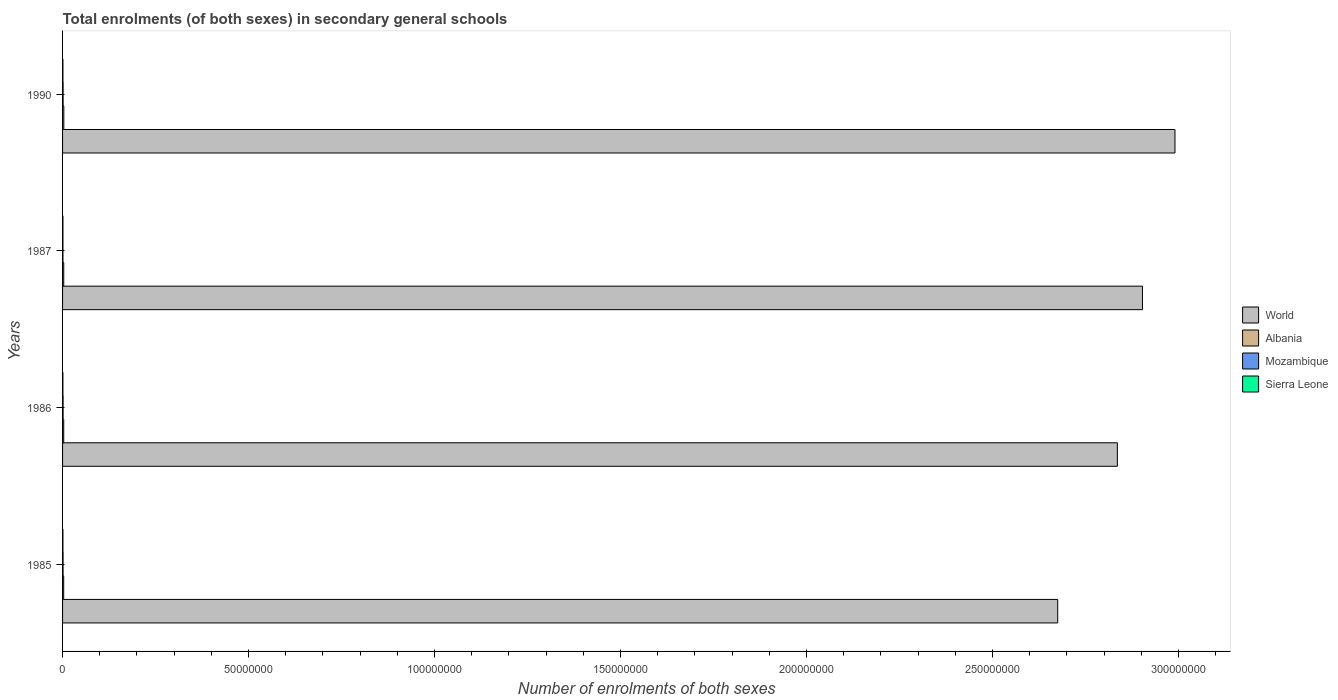How many bars are there on the 4th tick from the top?
Your answer should be very brief. 4. What is the label of the 3rd group of bars from the top?
Keep it short and to the point. 1986. In how many cases, is the number of bars for a given year not equal to the number of legend labels?
Give a very brief answer. 0. What is the number of enrolments in secondary schools in World in 1985?
Give a very brief answer. 2.68e+08. Across all years, what is the maximum number of enrolments in secondary schools in World?
Ensure brevity in your answer.  2.99e+08. Across all years, what is the minimum number of enrolments in secondary schools in World?
Provide a short and direct response. 2.68e+08. In which year was the number of enrolments in secondary schools in Albania maximum?
Your answer should be compact. 1990. In which year was the number of enrolments in secondary schools in World minimum?
Give a very brief answer. 1985. What is the total number of enrolments in secondary schools in Albania in the graph?
Your answer should be compact. 1.27e+06. What is the difference between the number of enrolments in secondary schools in Sierra Leone in 1986 and that in 1987?
Provide a succinct answer. -8178. What is the difference between the number of enrolments in secondary schools in Sierra Leone in 1990 and the number of enrolments in secondary schools in Albania in 1987?
Your response must be concise. -2.19e+05. What is the average number of enrolments in secondary schools in Albania per year?
Offer a terse response. 3.16e+05. In the year 1985, what is the difference between the number of enrolments in secondary schools in Albania and number of enrolments in secondary schools in Mozambique?
Provide a short and direct response. 1.68e+05. In how many years, is the number of enrolments in secondary schools in Albania greater than 70000000 ?
Offer a terse response. 0. What is the ratio of the number of enrolments in secondary schools in Albania in 1985 to that in 1986?
Ensure brevity in your answer.  0.97. Is the difference between the number of enrolments in secondary schools in Albania in 1985 and 1987 greater than the difference between the number of enrolments in secondary schools in Mozambique in 1985 and 1987?
Ensure brevity in your answer.  No. What is the difference between the highest and the second highest number of enrolments in secondary schools in Albania?
Ensure brevity in your answer.  1.91e+04. What is the difference between the highest and the lowest number of enrolments in secondary schools in Mozambique?
Your response must be concise. 4.20e+04. In how many years, is the number of enrolments in secondary schools in World greater than the average number of enrolments in secondary schools in World taken over all years?
Ensure brevity in your answer.  2. Is the sum of the number of enrolments in secondary schools in Albania in 1986 and 1987 greater than the maximum number of enrolments in secondary schools in World across all years?
Your response must be concise. No. What does the 1st bar from the top in 1987 represents?
Provide a succinct answer. Sierra Leone. How many bars are there?
Your answer should be very brief. 16. Are all the bars in the graph horizontal?
Offer a terse response. Yes. How many years are there in the graph?
Offer a very short reply. 4. Are the values on the major ticks of X-axis written in scientific E-notation?
Make the answer very short. No. Does the graph contain grids?
Offer a very short reply. No. Where does the legend appear in the graph?
Provide a short and direct response. Center right. How many legend labels are there?
Provide a succinct answer. 4. How are the legend labels stacked?
Keep it short and to the point. Vertical. What is the title of the graph?
Your answer should be compact. Total enrolments (of both sexes) in secondary general schools. What is the label or title of the X-axis?
Offer a terse response. Number of enrolments of both sexes. What is the Number of enrolments of both sexes in World in 1985?
Provide a succinct answer. 2.68e+08. What is the Number of enrolments of both sexes in Albania in 1985?
Offer a terse response. 3.03e+05. What is the Number of enrolments of both sexes of Mozambique in 1985?
Your response must be concise. 1.35e+05. What is the Number of enrolments of both sexes in Sierra Leone in 1985?
Your answer should be very brief. 9.71e+04. What is the Number of enrolments of both sexes in World in 1986?
Ensure brevity in your answer.  2.84e+08. What is the Number of enrolments of both sexes in Albania in 1986?
Give a very brief answer. 3.11e+05. What is the Number of enrolments of both sexes in Mozambique in 1986?
Give a very brief answer. 1.40e+05. What is the Number of enrolments of both sexes in Sierra Leone in 1986?
Your answer should be compact. 9.35e+04. What is the Number of enrolments of both sexes of World in 1987?
Keep it short and to the point. 2.90e+08. What is the Number of enrolments of both sexes in Albania in 1987?
Your answer should be very brief. 3.16e+05. What is the Number of enrolments of both sexes in Mozambique in 1987?
Ensure brevity in your answer.  1.03e+05. What is the Number of enrolments of both sexes in Sierra Leone in 1987?
Your answer should be compact. 1.02e+05. What is the Number of enrolments of both sexes in World in 1990?
Provide a short and direct response. 2.99e+08. What is the Number of enrolments of both sexes of Albania in 1990?
Provide a succinct answer. 3.35e+05. What is the Number of enrolments of both sexes in Mozambique in 1990?
Give a very brief answer. 1.45e+05. What is the Number of enrolments of both sexes in Sierra Leone in 1990?
Provide a succinct answer. 9.67e+04. Across all years, what is the maximum Number of enrolments of both sexes in World?
Ensure brevity in your answer.  2.99e+08. Across all years, what is the maximum Number of enrolments of both sexes of Albania?
Ensure brevity in your answer.  3.35e+05. Across all years, what is the maximum Number of enrolments of both sexes of Mozambique?
Make the answer very short. 1.45e+05. Across all years, what is the maximum Number of enrolments of both sexes of Sierra Leone?
Keep it short and to the point. 1.02e+05. Across all years, what is the minimum Number of enrolments of both sexes of World?
Keep it short and to the point. 2.68e+08. Across all years, what is the minimum Number of enrolments of both sexes of Albania?
Your answer should be very brief. 3.03e+05. Across all years, what is the minimum Number of enrolments of both sexes in Mozambique?
Your response must be concise. 1.03e+05. Across all years, what is the minimum Number of enrolments of both sexes in Sierra Leone?
Your answer should be compact. 9.35e+04. What is the total Number of enrolments of both sexes in World in the graph?
Make the answer very short. 1.14e+09. What is the total Number of enrolments of both sexes of Albania in the graph?
Your answer should be very brief. 1.27e+06. What is the total Number of enrolments of both sexes of Mozambique in the graph?
Ensure brevity in your answer.  5.24e+05. What is the total Number of enrolments of both sexes in Sierra Leone in the graph?
Your response must be concise. 3.89e+05. What is the difference between the Number of enrolments of both sexes in World in 1985 and that in 1986?
Offer a terse response. -1.60e+07. What is the difference between the Number of enrolments of both sexes of Albania in 1985 and that in 1986?
Provide a succinct answer. -8208. What is the difference between the Number of enrolments of both sexes in Mozambique in 1985 and that in 1986?
Provide a succinct answer. -4947. What is the difference between the Number of enrolments of both sexes in Sierra Leone in 1985 and that in 1986?
Offer a very short reply. 3628. What is the difference between the Number of enrolments of both sexes of World in 1985 and that in 1987?
Ensure brevity in your answer.  -2.28e+07. What is the difference between the Number of enrolments of both sexes of Albania in 1985 and that in 1987?
Keep it short and to the point. -1.31e+04. What is the difference between the Number of enrolments of both sexes of Mozambique in 1985 and that in 1987?
Offer a very short reply. 3.17e+04. What is the difference between the Number of enrolments of both sexes in Sierra Leone in 1985 and that in 1987?
Offer a very short reply. -4550. What is the difference between the Number of enrolments of both sexes of World in 1985 and that in 1990?
Your answer should be very brief. -3.15e+07. What is the difference between the Number of enrolments of both sexes in Albania in 1985 and that in 1990?
Ensure brevity in your answer.  -3.22e+04. What is the difference between the Number of enrolments of both sexes of Mozambique in 1985 and that in 1990?
Offer a terse response. -1.03e+04. What is the difference between the Number of enrolments of both sexes in Sierra Leone in 1985 and that in 1990?
Your answer should be very brief. 428. What is the difference between the Number of enrolments of both sexes of World in 1986 and that in 1987?
Offer a terse response. -6.75e+06. What is the difference between the Number of enrolments of both sexes in Albania in 1986 and that in 1987?
Provide a succinct answer. -4899. What is the difference between the Number of enrolments of both sexes in Mozambique in 1986 and that in 1987?
Provide a succinct answer. 3.67e+04. What is the difference between the Number of enrolments of both sexes of Sierra Leone in 1986 and that in 1987?
Provide a succinct answer. -8178. What is the difference between the Number of enrolments of both sexes of World in 1986 and that in 1990?
Offer a very short reply. -1.55e+07. What is the difference between the Number of enrolments of both sexes of Albania in 1986 and that in 1990?
Your answer should be very brief. -2.40e+04. What is the difference between the Number of enrolments of both sexes in Mozambique in 1986 and that in 1990?
Your response must be concise. -5326. What is the difference between the Number of enrolments of both sexes of Sierra Leone in 1986 and that in 1990?
Offer a terse response. -3200. What is the difference between the Number of enrolments of both sexes of World in 1987 and that in 1990?
Keep it short and to the point. -8.73e+06. What is the difference between the Number of enrolments of both sexes of Albania in 1987 and that in 1990?
Provide a short and direct response. -1.91e+04. What is the difference between the Number of enrolments of both sexes of Mozambique in 1987 and that in 1990?
Provide a succinct answer. -4.20e+04. What is the difference between the Number of enrolments of both sexes of Sierra Leone in 1987 and that in 1990?
Offer a terse response. 4978. What is the difference between the Number of enrolments of both sexes of World in 1985 and the Number of enrolments of both sexes of Albania in 1986?
Offer a very short reply. 2.67e+08. What is the difference between the Number of enrolments of both sexes of World in 1985 and the Number of enrolments of both sexes of Mozambique in 1986?
Ensure brevity in your answer.  2.67e+08. What is the difference between the Number of enrolments of both sexes in World in 1985 and the Number of enrolments of both sexes in Sierra Leone in 1986?
Offer a terse response. 2.67e+08. What is the difference between the Number of enrolments of both sexes of Albania in 1985 and the Number of enrolments of both sexes of Mozambique in 1986?
Ensure brevity in your answer.  1.63e+05. What is the difference between the Number of enrolments of both sexes in Albania in 1985 and the Number of enrolments of both sexes in Sierra Leone in 1986?
Make the answer very short. 2.10e+05. What is the difference between the Number of enrolments of both sexes of Mozambique in 1985 and the Number of enrolments of both sexes of Sierra Leone in 1986?
Provide a succinct answer. 4.16e+04. What is the difference between the Number of enrolments of both sexes in World in 1985 and the Number of enrolments of both sexes in Albania in 1987?
Provide a short and direct response. 2.67e+08. What is the difference between the Number of enrolments of both sexes in World in 1985 and the Number of enrolments of both sexes in Mozambique in 1987?
Make the answer very short. 2.67e+08. What is the difference between the Number of enrolments of both sexes in World in 1985 and the Number of enrolments of both sexes in Sierra Leone in 1987?
Give a very brief answer. 2.67e+08. What is the difference between the Number of enrolments of both sexes in Albania in 1985 and the Number of enrolments of both sexes in Mozambique in 1987?
Keep it short and to the point. 2.00e+05. What is the difference between the Number of enrolments of both sexes in Albania in 1985 and the Number of enrolments of both sexes in Sierra Leone in 1987?
Offer a terse response. 2.01e+05. What is the difference between the Number of enrolments of both sexes of Mozambique in 1985 and the Number of enrolments of both sexes of Sierra Leone in 1987?
Offer a very short reply. 3.34e+04. What is the difference between the Number of enrolments of both sexes in World in 1985 and the Number of enrolments of both sexes in Albania in 1990?
Make the answer very short. 2.67e+08. What is the difference between the Number of enrolments of both sexes of World in 1985 and the Number of enrolments of both sexes of Mozambique in 1990?
Make the answer very short. 2.67e+08. What is the difference between the Number of enrolments of both sexes of World in 1985 and the Number of enrolments of both sexes of Sierra Leone in 1990?
Ensure brevity in your answer.  2.67e+08. What is the difference between the Number of enrolments of both sexes of Albania in 1985 and the Number of enrolments of both sexes of Mozambique in 1990?
Ensure brevity in your answer.  1.58e+05. What is the difference between the Number of enrolments of both sexes of Albania in 1985 and the Number of enrolments of both sexes of Sierra Leone in 1990?
Keep it short and to the point. 2.06e+05. What is the difference between the Number of enrolments of both sexes of Mozambique in 1985 and the Number of enrolments of both sexes of Sierra Leone in 1990?
Ensure brevity in your answer.  3.84e+04. What is the difference between the Number of enrolments of both sexes in World in 1986 and the Number of enrolments of both sexes in Albania in 1987?
Offer a very short reply. 2.83e+08. What is the difference between the Number of enrolments of both sexes of World in 1986 and the Number of enrolments of both sexes of Mozambique in 1987?
Offer a very short reply. 2.83e+08. What is the difference between the Number of enrolments of both sexes of World in 1986 and the Number of enrolments of both sexes of Sierra Leone in 1987?
Ensure brevity in your answer.  2.83e+08. What is the difference between the Number of enrolments of both sexes of Albania in 1986 and the Number of enrolments of both sexes of Mozambique in 1987?
Offer a very short reply. 2.08e+05. What is the difference between the Number of enrolments of both sexes in Albania in 1986 and the Number of enrolments of both sexes in Sierra Leone in 1987?
Make the answer very short. 2.10e+05. What is the difference between the Number of enrolments of both sexes of Mozambique in 1986 and the Number of enrolments of both sexes of Sierra Leone in 1987?
Ensure brevity in your answer.  3.83e+04. What is the difference between the Number of enrolments of both sexes of World in 1986 and the Number of enrolments of both sexes of Albania in 1990?
Keep it short and to the point. 2.83e+08. What is the difference between the Number of enrolments of both sexes in World in 1986 and the Number of enrolments of both sexes in Mozambique in 1990?
Keep it short and to the point. 2.83e+08. What is the difference between the Number of enrolments of both sexes of World in 1986 and the Number of enrolments of both sexes of Sierra Leone in 1990?
Ensure brevity in your answer.  2.83e+08. What is the difference between the Number of enrolments of both sexes of Albania in 1986 and the Number of enrolments of both sexes of Mozambique in 1990?
Your answer should be compact. 1.66e+05. What is the difference between the Number of enrolments of both sexes in Albania in 1986 and the Number of enrolments of both sexes in Sierra Leone in 1990?
Your answer should be very brief. 2.15e+05. What is the difference between the Number of enrolments of both sexes of Mozambique in 1986 and the Number of enrolments of both sexes of Sierra Leone in 1990?
Provide a short and direct response. 4.33e+04. What is the difference between the Number of enrolments of both sexes in World in 1987 and the Number of enrolments of both sexes in Albania in 1990?
Keep it short and to the point. 2.90e+08. What is the difference between the Number of enrolments of both sexes of World in 1987 and the Number of enrolments of both sexes of Mozambique in 1990?
Give a very brief answer. 2.90e+08. What is the difference between the Number of enrolments of both sexes of World in 1987 and the Number of enrolments of both sexes of Sierra Leone in 1990?
Offer a very short reply. 2.90e+08. What is the difference between the Number of enrolments of both sexes in Albania in 1987 and the Number of enrolments of both sexes in Mozambique in 1990?
Offer a terse response. 1.71e+05. What is the difference between the Number of enrolments of both sexes in Albania in 1987 and the Number of enrolments of both sexes in Sierra Leone in 1990?
Ensure brevity in your answer.  2.19e+05. What is the difference between the Number of enrolments of both sexes of Mozambique in 1987 and the Number of enrolments of both sexes of Sierra Leone in 1990?
Offer a terse response. 6613. What is the average Number of enrolments of both sexes of World per year?
Ensure brevity in your answer.  2.85e+08. What is the average Number of enrolments of both sexes in Albania per year?
Your answer should be compact. 3.16e+05. What is the average Number of enrolments of both sexes of Mozambique per year?
Provide a short and direct response. 1.31e+05. What is the average Number of enrolments of both sexes of Sierra Leone per year?
Provide a succinct answer. 9.73e+04. In the year 1985, what is the difference between the Number of enrolments of both sexes of World and Number of enrolments of both sexes of Albania?
Provide a short and direct response. 2.67e+08. In the year 1985, what is the difference between the Number of enrolments of both sexes in World and Number of enrolments of both sexes in Mozambique?
Your response must be concise. 2.67e+08. In the year 1985, what is the difference between the Number of enrolments of both sexes in World and Number of enrolments of both sexes in Sierra Leone?
Provide a short and direct response. 2.67e+08. In the year 1985, what is the difference between the Number of enrolments of both sexes of Albania and Number of enrolments of both sexes of Mozambique?
Give a very brief answer. 1.68e+05. In the year 1985, what is the difference between the Number of enrolments of both sexes in Albania and Number of enrolments of both sexes in Sierra Leone?
Your response must be concise. 2.06e+05. In the year 1985, what is the difference between the Number of enrolments of both sexes of Mozambique and Number of enrolments of both sexes of Sierra Leone?
Your response must be concise. 3.79e+04. In the year 1986, what is the difference between the Number of enrolments of both sexes of World and Number of enrolments of both sexes of Albania?
Your answer should be compact. 2.83e+08. In the year 1986, what is the difference between the Number of enrolments of both sexes in World and Number of enrolments of both sexes in Mozambique?
Ensure brevity in your answer.  2.83e+08. In the year 1986, what is the difference between the Number of enrolments of both sexes in World and Number of enrolments of both sexes in Sierra Leone?
Provide a succinct answer. 2.83e+08. In the year 1986, what is the difference between the Number of enrolments of both sexes in Albania and Number of enrolments of both sexes in Mozambique?
Give a very brief answer. 1.71e+05. In the year 1986, what is the difference between the Number of enrolments of both sexes of Albania and Number of enrolments of both sexes of Sierra Leone?
Provide a succinct answer. 2.18e+05. In the year 1986, what is the difference between the Number of enrolments of both sexes in Mozambique and Number of enrolments of both sexes in Sierra Leone?
Offer a terse response. 4.65e+04. In the year 1987, what is the difference between the Number of enrolments of both sexes in World and Number of enrolments of both sexes in Albania?
Your answer should be compact. 2.90e+08. In the year 1987, what is the difference between the Number of enrolments of both sexes in World and Number of enrolments of both sexes in Mozambique?
Your answer should be very brief. 2.90e+08. In the year 1987, what is the difference between the Number of enrolments of both sexes of World and Number of enrolments of both sexes of Sierra Leone?
Provide a short and direct response. 2.90e+08. In the year 1987, what is the difference between the Number of enrolments of both sexes in Albania and Number of enrolments of both sexes in Mozambique?
Provide a short and direct response. 2.13e+05. In the year 1987, what is the difference between the Number of enrolments of both sexes in Albania and Number of enrolments of both sexes in Sierra Leone?
Provide a short and direct response. 2.14e+05. In the year 1987, what is the difference between the Number of enrolments of both sexes in Mozambique and Number of enrolments of both sexes in Sierra Leone?
Make the answer very short. 1635. In the year 1990, what is the difference between the Number of enrolments of both sexes in World and Number of enrolments of both sexes in Albania?
Your response must be concise. 2.99e+08. In the year 1990, what is the difference between the Number of enrolments of both sexes in World and Number of enrolments of both sexes in Mozambique?
Give a very brief answer. 2.99e+08. In the year 1990, what is the difference between the Number of enrolments of both sexes in World and Number of enrolments of both sexes in Sierra Leone?
Make the answer very short. 2.99e+08. In the year 1990, what is the difference between the Number of enrolments of both sexes in Albania and Number of enrolments of both sexes in Mozambique?
Provide a short and direct response. 1.90e+05. In the year 1990, what is the difference between the Number of enrolments of both sexes of Albania and Number of enrolments of both sexes of Sierra Leone?
Offer a very short reply. 2.39e+05. In the year 1990, what is the difference between the Number of enrolments of both sexes of Mozambique and Number of enrolments of both sexes of Sierra Leone?
Your response must be concise. 4.86e+04. What is the ratio of the Number of enrolments of both sexes in World in 1985 to that in 1986?
Give a very brief answer. 0.94. What is the ratio of the Number of enrolments of both sexes of Albania in 1985 to that in 1986?
Offer a terse response. 0.97. What is the ratio of the Number of enrolments of both sexes of Mozambique in 1985 to that in 1986?
Keep it short and to the point. 0.96. What is the ratio of the Number of enrolments of both sexes in Sierra Leone in 1985 to that in 1986?
Make the answer very short. 1.04. What is the ratio of the Number of enrolments of both sexes of World in 1985 to that in 1987?
Offer a very short reply. 0.92. What is the ratio of the Number of enrolments of both sexes in Albania in 1985 to that in 1987?
Ensure brevity in your answer.  0.96. What is the ratio of the Number of enrolments of both sexes in Mozambique in 1985 to that in 1987?
Offer a terse response. 1.31. What is the ratio of the Number of enrolments of both sexes in Sierra Leone in 1985 to that in 1987?
Your response must be concise. 0.96. What is the ratio of the Number of enrolments of both sexes of World in 1985 to that in 1990?
Give a very brief answer. 0.89. What is the ratio of the Number of enrolments of both sexes in Albania in 1985 to that in 1990?
Ensure brevity in your answer.  0.9. What is the ratio of the Number of enrolments of both sexes of Mozambique in 1985 to that in 1990?
Ensure brevity in your answer.  0.93. What is the ratio of the Number of enrolments of both sexes in Sierra Leone in 1985 to that in 1990?
Your response must be concise. 1. What is the ratio of the Number of enrolments of both sexes of World in 1986 to that in 1987?
Offer a very short reply. 0.98. What is the ratio of the Number of enrolments of both sexes of Albania in 1986 to that in 1987?
Your answer should be compact. 0.98. What is the ratio of the Number of enrolments of both sexes in Mozambique in 1986 to that in 1987?
Your response must be concise. 1.36. What is the ratio of the Number of enrolments of both sexes of Sierra Leone in 1986 to that in 1987?
Give a very brief answer. 0.92. What is the ratio of the Number of enrolments of both sexes of World in 1986 to that in 1990?
Provide a succinct answer. 0.95. What is the ratio of the Number of enrolments of both sexes in Albania in 1986 to that in 1990?
Make the answer very short. 0.93. What is the ratio of the Number of enrolments of both sexes of Mozambique in 1986 to that in 1990?
Ensure brevity in your answer.  0.96. What is the ratio of the Number of enrolments of both sexes of Sierra Leone in 1986 to that in 1990?
Make the answer very short. 0.97. What is the ratio of the Number of enrolments of both sexes in World in 1987 to that in 1990?
Give a very brief answer. 0.97. What is the ratio of the Number of enrolments of both sexes in Albania in 1987 to that in 1990?
Your answer should be compact. 0.94. What is the ratio of the Number of enrolments of both sexes of Mozambique in 1987 to that in 1990?
Offer a terse response. 0.71. What is the ratio of the Number of enrolments of both sexes in Sierra Leone in 1987 to that in 1990?
Provide a succinct answer. 1.05. What is the difference between the highest and the second highest Number of enrolments of both sexes of World?
Offer a terse response. 8.73e+06. What is the difference between the highest and the second highest Number of enrolments of both sexes of Albania?
Provide a short and direct response. 1.91e+04. What is the difference between the highest and the second highest Number of enrolments of both sexes of Mozambique?
Give a very brief answer. 5326. What is the difference between the highest and the second highest Number of enrolments of both sexes in Sierra Leone?
Your response must be concise. 4550. What is the difference between the highest and the lowest Number of enrolments of both sexes of World?
Provide a short and direct response. 3.15e+07. What is the difference between the highest and the lowest Number of enrolments of both sexes in Albania?
Make the answer very short. 3.22e+04. What is the difference between the highest and the lowest Number of enrolments of both sexes in Mozambique?
Keep it short and to the point. 4.20e+04. What is the difference between the highest and the lowest Number of enrolments of both sexes of Sierra Leone?
Make the answer very short. 8178. 